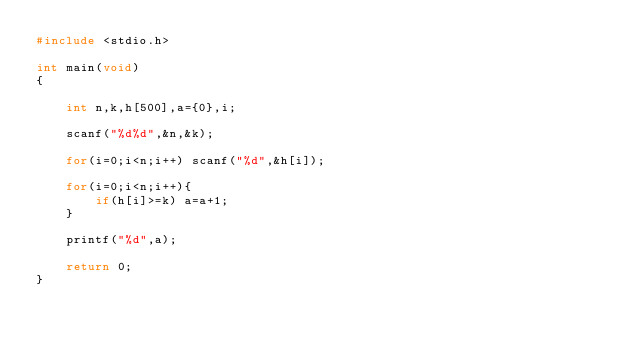<code> <loc_0><loc_0><loc_500><loc_500><_C_>#include <stdio.h>
 
int main(void)
{
  
    int n,k,h[500],a={0},i; 
      
    scanf("%d%d",&n,&k);
  
    for(i=0;i<n;i++) scanf("%d",&h[i]);
        
    for(i=0;i<n;i++){
        if(h[i]>=k) a=a+1;
    }
  
    printf("%d",a);
  
    return 0;
}  </code> 